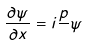<formula> <loc_0><loc_0><loc_500><loc_500>\frac { \partial \psi } { \partial x } = i \frac { p } { } \psi</formula> 